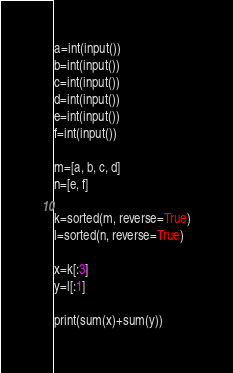Convert code to text. <code><loc_0><loc_0><loc_500><loc_500><_Python_>a=int(input())
b=int(input())
c=int(input())
d=int(input())
e=int(input())
f=int(input())

m=[a, b, c, d]
n=[e, f]

k=sorted(m, reverse=True)
l=sorted(n, reverse=True)

x=k[:3]
y=l[:1]

print(sum(x)+sum(y))

</code> 